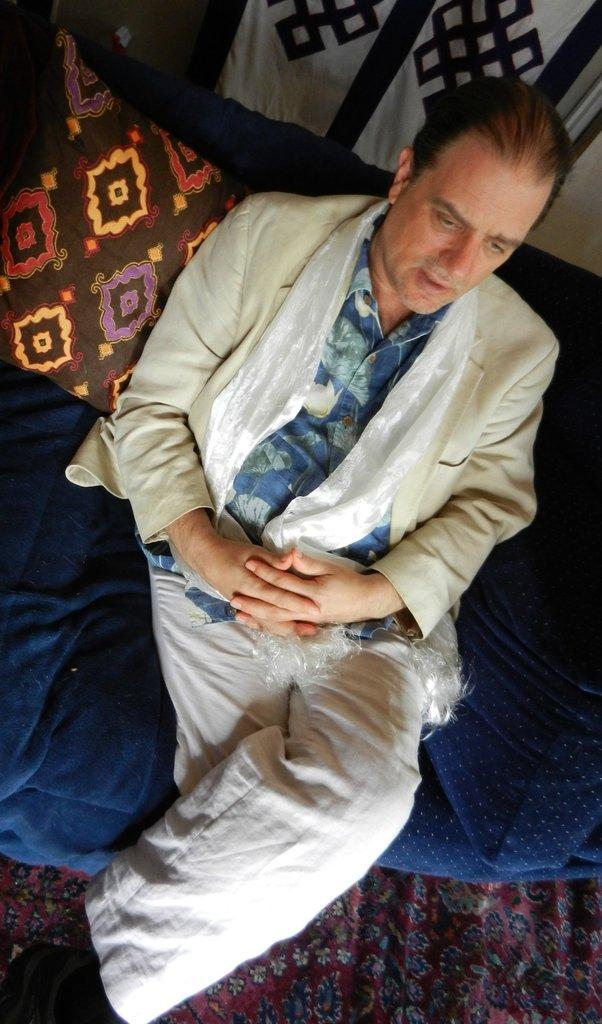Who is present in the image? There is a man in the image. What is the man wearing? The man is wearing a white suit. What is the man doing in the image? The man is sitting on a sofa. What can be seen on the wall behind the man? There is a cloth on the wall behind the man. How many dogs are present in the image? There are no dogs present in the image. What type of ice can be seen melting on the man's suit? There is no ice present in the image, and therefore no ice can be seen melting on the man's suit. 